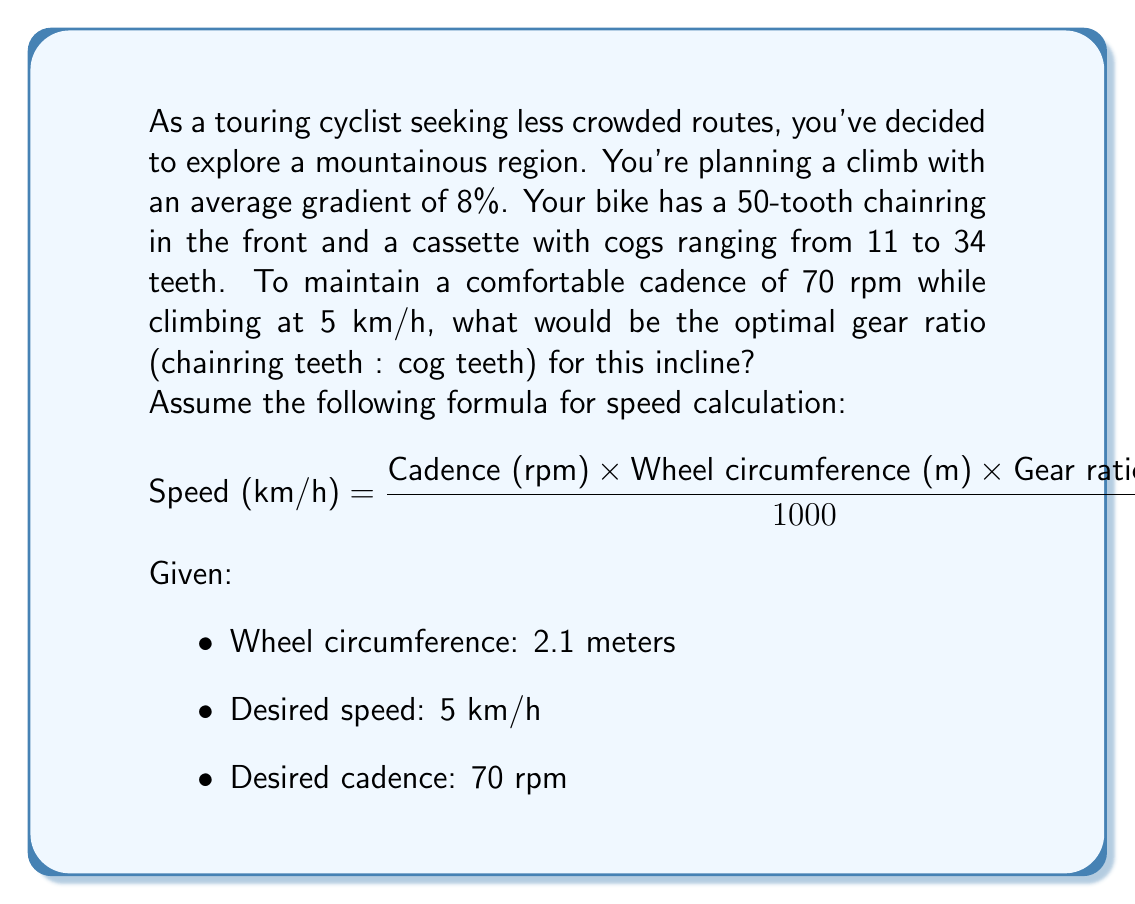What is the answer to this math problem? To solve this problem, we'll use the given formula and work backwards to find the optimal gear ratio:

1) Start with the speed formula and substitute the known values:

$$ 5 = \frac{70 \times 2.1 \times \text{Gear ratio} \times 60}{1000} $$

2) Simplify the right side of the equation:

$$ 5 = 8.82 \times \text{Gear ratio} $$

3) Solve for the gear ratio:

$$ \text{Gear ratio} = \frac{5}{8.82} \approx 0.567 $$

4) The gear ratio is the number of teeth on the chainring divided by the number of teeth on the cog. We know we have a 50-tooth chainring, so:

$$ 0.567 = \frac{50}{\text{Cog teeth}} $$

5) Solve for the number of cog teeth:

$$ \text{Cog teeth} = \frac{50}{0.567} \approx 88.2 $$

6) Since we don't have an 88-tooth cog, we need to find the closest available option. The largest cog on the cassette is 34 teeth.

7) Calculate the actual gear ratio with the 34-tooth cog:

$$ \text{Actual gear ratio} = \frac{50}{34} \approx 1.47 $$

8) Express this as a ratio of chainring teeth to cog teeth:

$$ 50:34 \approx 1.47:1 $$
Answer: The optimal gear ratio for the given conditions is approximately 50:34 or 1.47:1, using the largest available cog (34 teeth) with the 50-tooth chainring. 